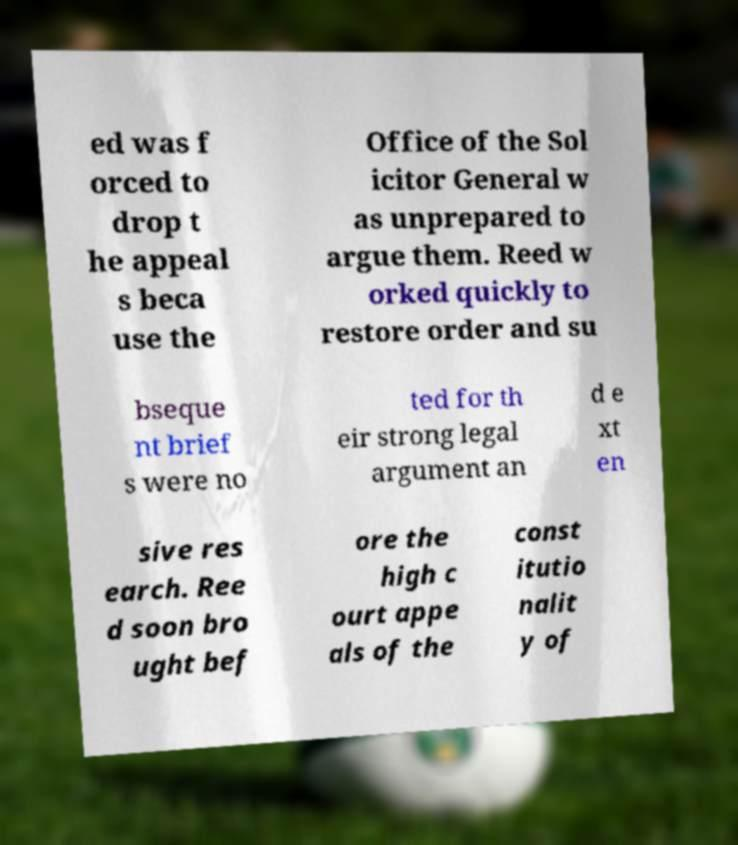Please read and relay the text visible in this image. What does it say? ed was f orced to drop t he appeal s beca use the Office of the Sol icitor General w as unprepared to argue them. Reed w orked quickly to restore order and su bseque nt brief s were no ted for th eir strong legal argument an d e xt en sive res earch. Ree d soon bro ught bef ore the high c ourt appe als of the const itutio nalit y of 